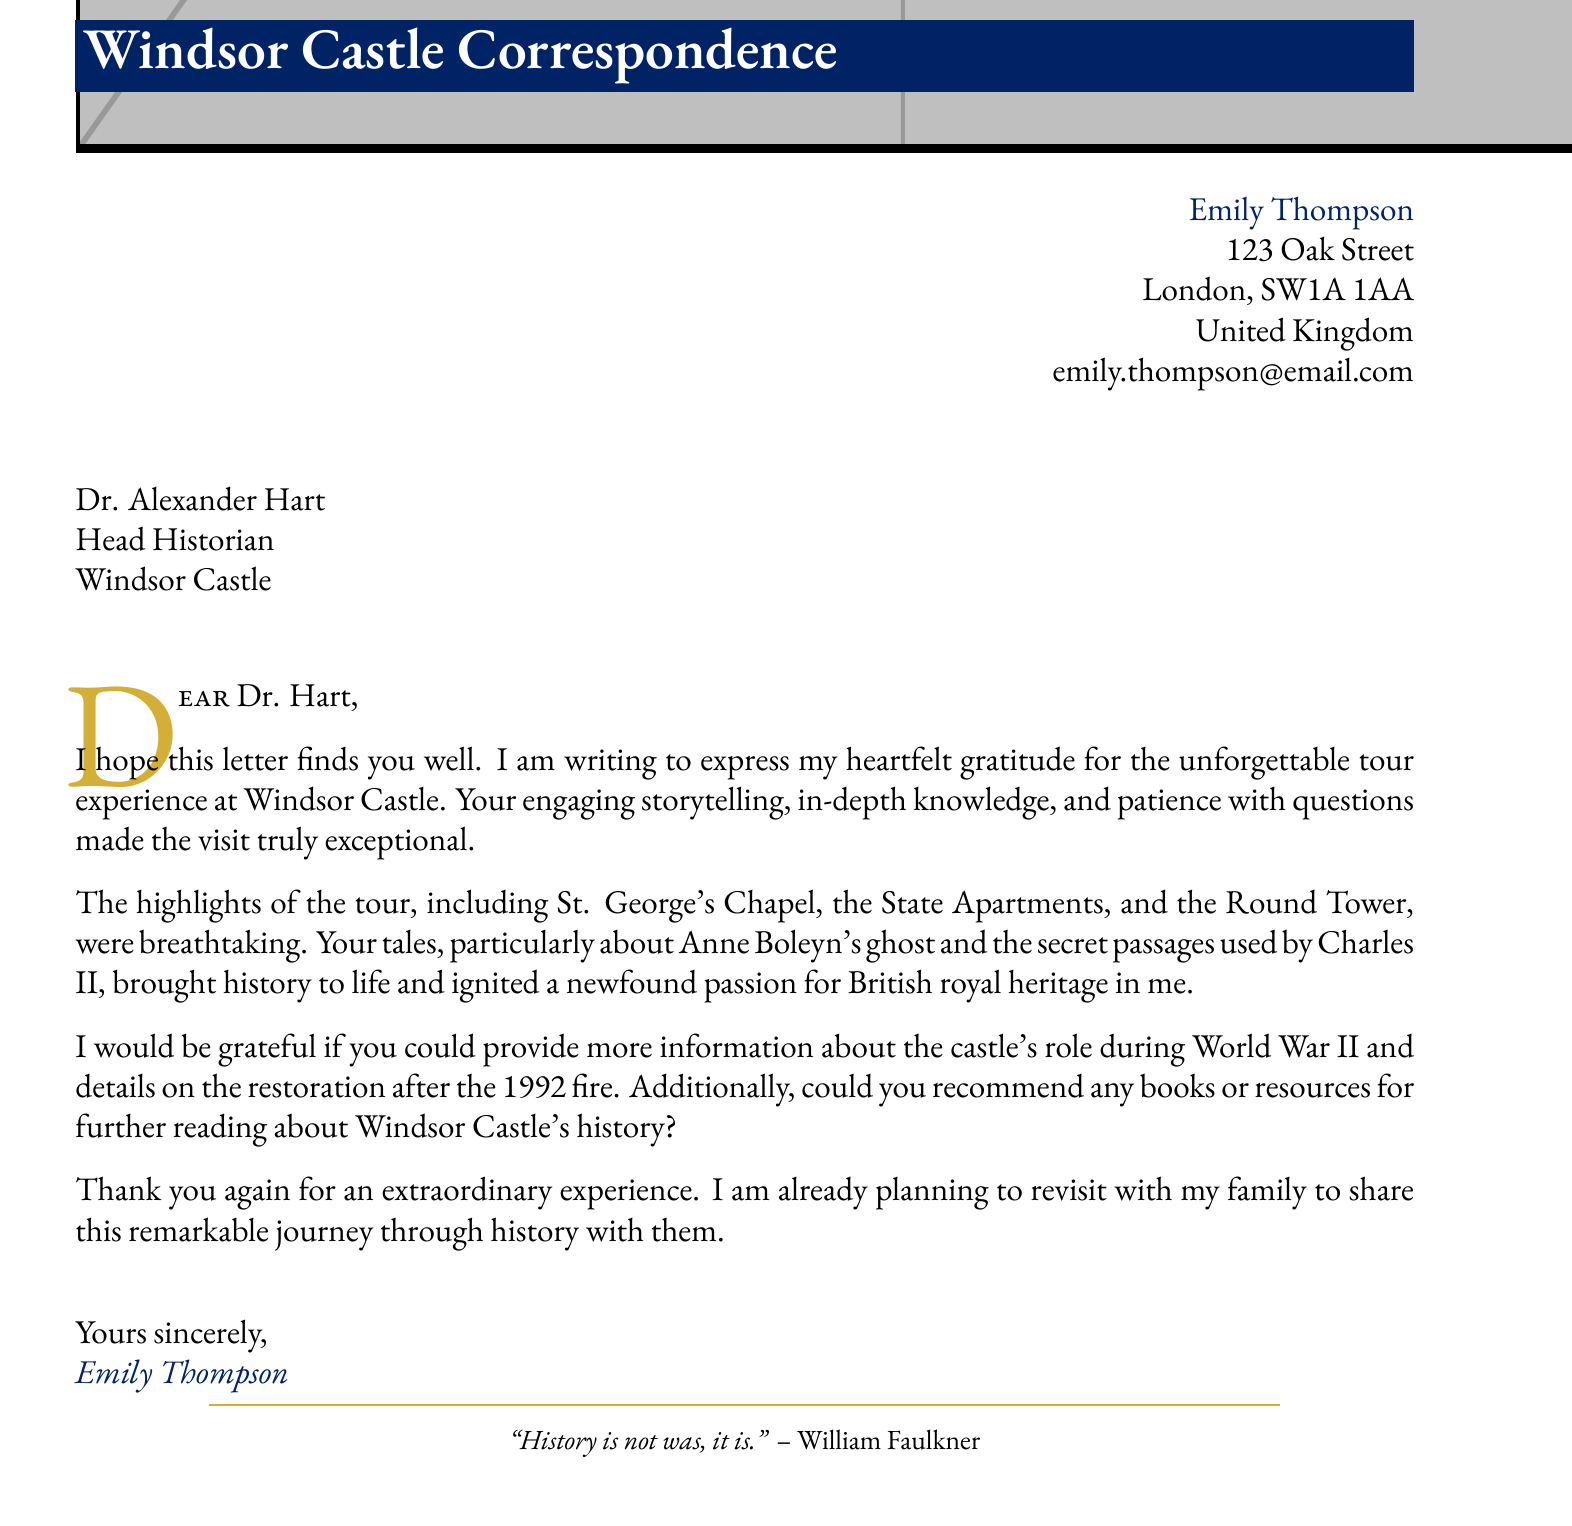What is the sender's name? The sender's name is clearly stated in the document's recipient information section as Emily Thompson.
Answer: Emily Thompson Who is the recipient of the letter? The recipient's information, including their title and location, is provided in the document: Dr. Alexander Hart, Head Historian at Windsor Castle.
Answer: Dr. Alexander Hart What were the highlighted tour locations? The document lists the key attractions highlighted during the tour, which include St. George's Chapel, State Apartments, and Round Tower.
Answer: St. George's Chapel, State Apartments, Round Tower What memorable story is mentioned in the letter? The letter describes a specific tale about Anne Boleyn's ghost, highlighting a memorable story shared during the tour.
Answer: Tale of Anne Boleyn's ghost What additional information does the sender request regarding World War II? The sender is asking for more details about how Windsor Castle was involved during World War II, indicating interest in historical events.
Answer: Castle's role during World War II What does the sender express about their tour experience? The sender reflects positively on the tour experience, emphasizing that it brought history to life and ignited a newfound passion for British royal heritage.
Answer: Brought history to life and ignited a newfound passion for British royal heritage How does Emily intend to share her experience in the future? In the closing remarks, Emily mentions her plans to revisit Windsor Castle with her family to share the stories and experiences.
Answer: Plans to revisit with family 